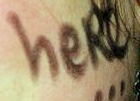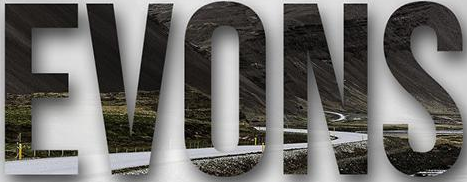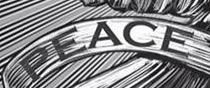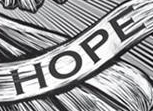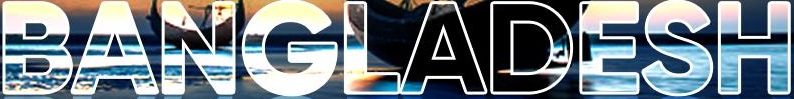Read the text from these images in sequence, separated by a semicolon. heRe; EVONS; PEACE; HOPE; BANGLADESH 